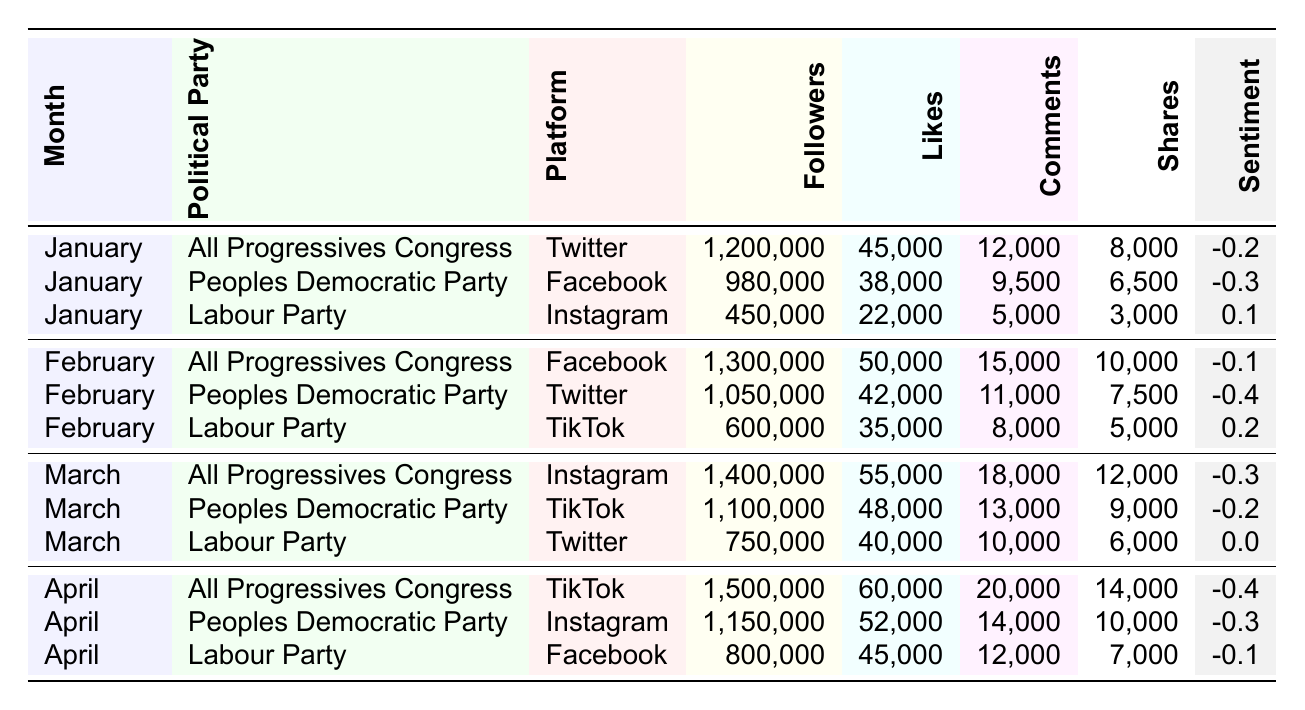What platform had the highest number of followers for the All Progressives Congress in April? In April, the All Progressives Congress had 1,500,000 followers on TikTok, which is the highest number of followers among all platforms for that political party.
Answer: TikTok Which political party received the most likes in March? In March, the All Progressives Congress received 55,000 likes, which is higher than the other parties' likes for that month (Peoples Democratic Party had 48,000 likes and Labour Party had 40,000 likes).
Answer: All Progressives Congress What is the average sentiment score for the Labour Party across the four months? The sentiment scores for the Labour Party are 0.1 (January), 0.2 (February), 0.0 (March), and -0.1 (April). The total sum is 0.1 + 0.2 + 0.0 - 0.1 = 0.2. Dividing by 4 (the number of months), the average sentiment score is 0.2/4 = 0.05.
Answer: 0.05 Did the Peoples Democratic Party have higher engagement (likes, comments, and shares) than the Labour Party in January? In January, the Peoples Democratic Party had 38,000 likes, 9,500 comments, and 6,500 shares, totaling 53,000 engagements. The Labour Party had 22,000 likes, 5,000 comments, and 3,000 shares, totaling 30,000 engagements. Since 53,000 is greater than 30,000, it confirms that the Peoples Democratic Party had higher engagement.
Answer: Yes Which political party had the largest increase in followers from January to April? The All Progressives Congress had 1,200,000 followers in January and 1,500,000 in April, which is an increase of 300,000 followers. The Peoples Democratic Party had 980,000 followers in January and 1,150,000 in April, increasing by 170,000. The Labour Party had 450,000 followers in January, rising to 800,000 in April, an increase of 350,000. This shows that the Labour Party had the largest increase overall.
Answer: Labour Party How do the shares for the Peoples Democratic Party in February compare to those in March? In February, the Peoples Democratic Party had 7,500 shares, while in March, they had 9,000 shares. This shows that the number of shares increased from February to March.
Answer: Increased What is the total number of likes received by the All Progressives Congress from January to April? The All Progressives Congress received 45,000 likes in January, 50,000 in February, 55,000 in March, and 60,000 in April. Adding these values together gives 45,000 + 50,000 + 55,000 + 60,000 = 210,000 likes in total.
Answer: 210,000 Was there a decline in the sentiment score for the Labour Party from January to April? The sentiment scores for the Labour Party were 0.1 in January and -0.1 in April. The decline from 0.1 to -0.1 confirms a decrease.
Answer: Yes 